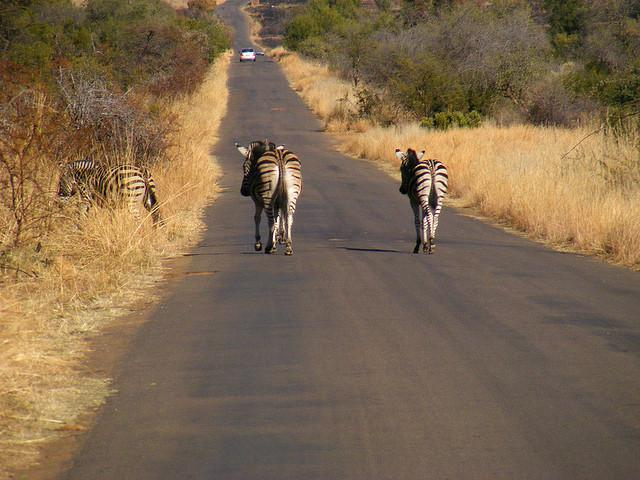What are the animals showing to the camera?

Choices:
A) tusks
B) backside
C) antlers
D) horns backside 